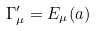Convert formula to latex. <formula><loc_0><loc_0><loc_500><loc_500>\Gamma ^ { \prime } _ { \mu } = E _ { \mu } ( a )</formula> 